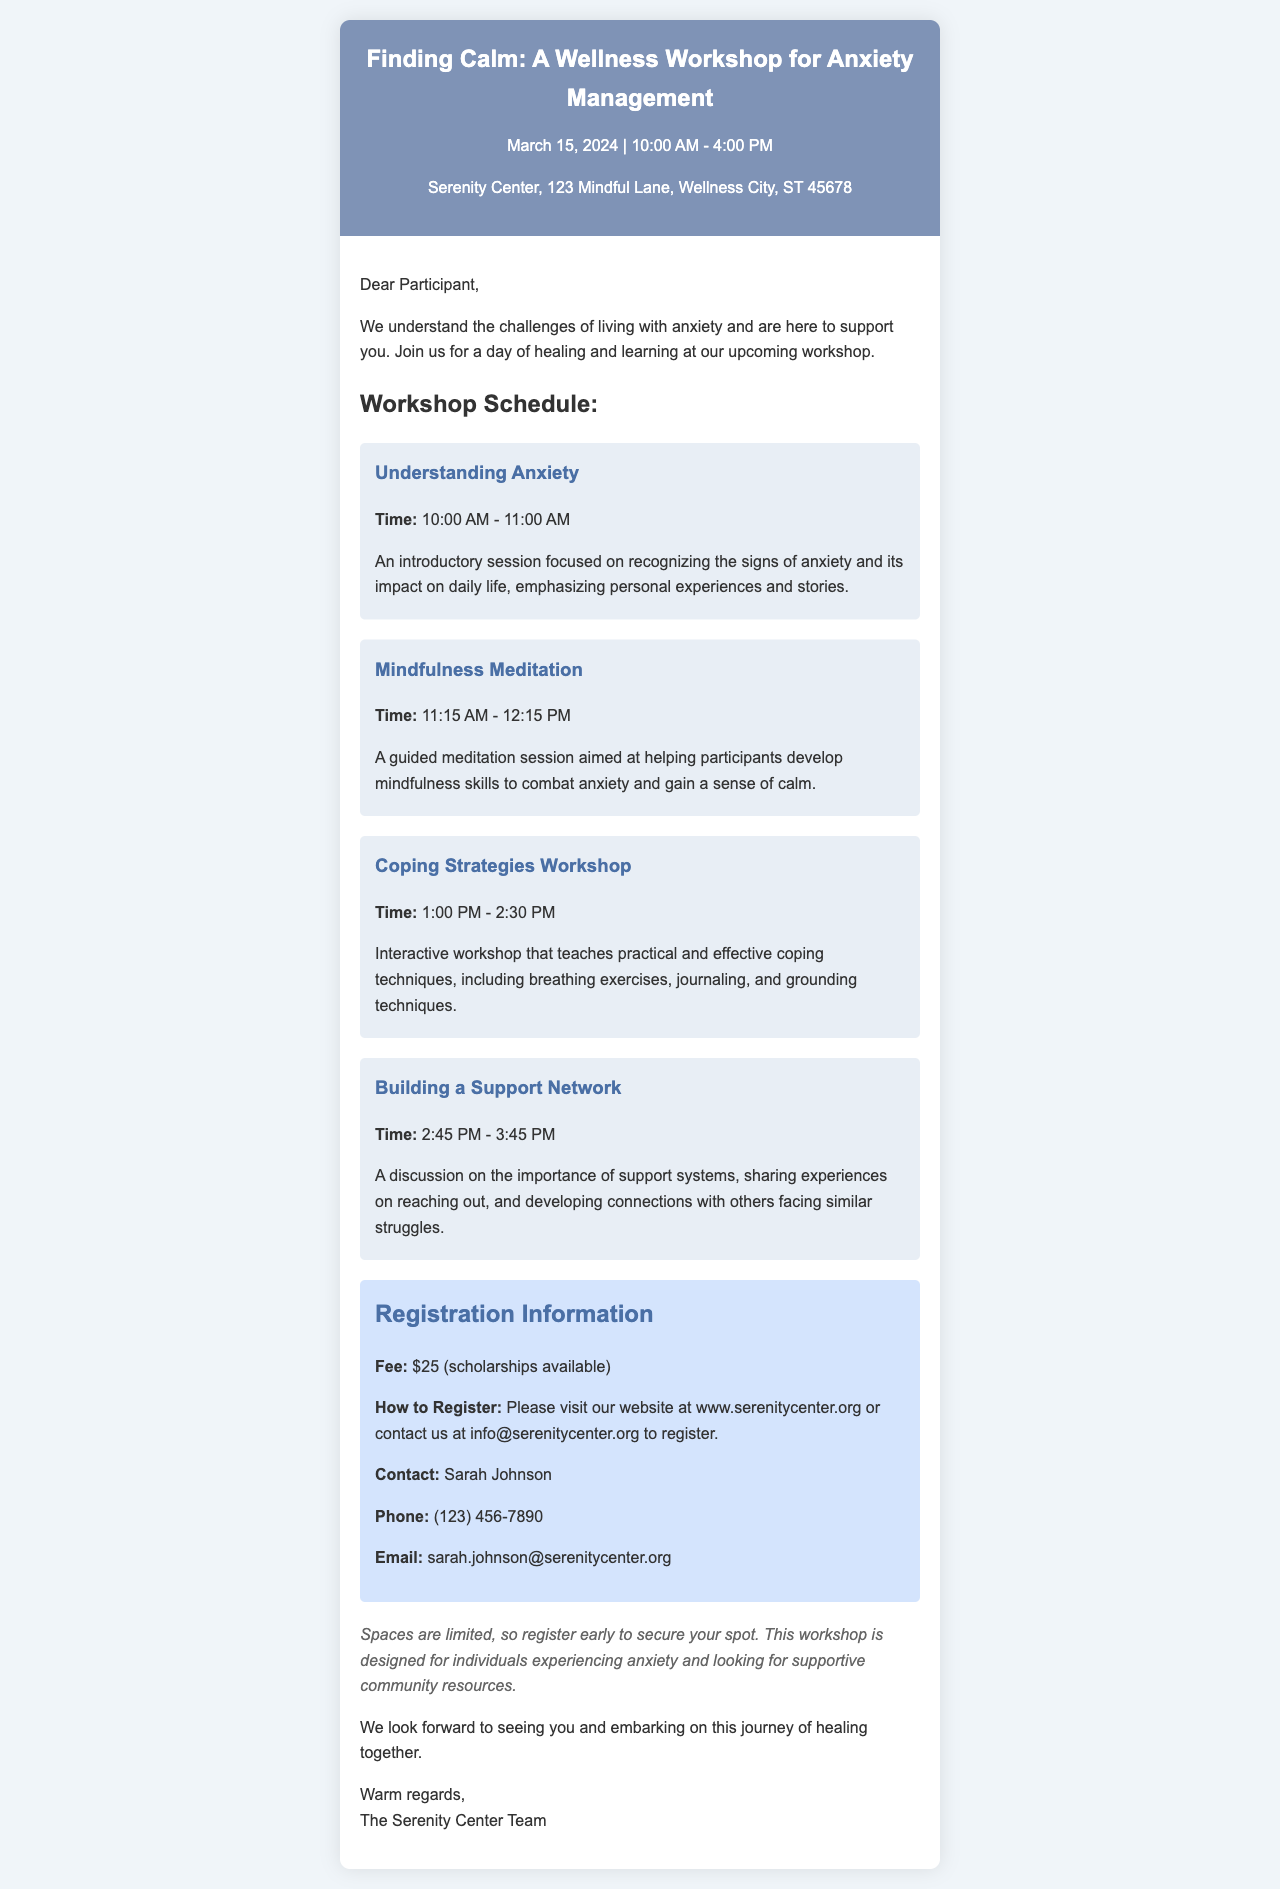What is the date of the workshop? The date of the workshop is mentioned in the header section of the document.
Answer: March 15, 2024 Where is the workshop being held? The location of the workshop is included in the header section of the document.
Answer: Serenity Center, 123 Mindful Lane, Wellness City, ST 45678 What is the registration fee? The registration fee is provided in the registration section of the document.
Answer: $25 Who should participants contact for more information? The contact person for more information is specified in the registration section.
Answer: Sarah Johnson What time does the "Coping Strategies Workshop" start? The start time for this workshop session is listed in the schedule section of the document.
Answer: 1:00 PM What type of techniques will be taught in the "Coping Strategies Workshop"? This session focuses on specific techniques mentioned in the session description.
Answer: Breathing exercises, journaling, and grounding techniques What is the duration of the "Mindfulness Meditation" session? The duration can be calculated from the start and end time provided in the session's description.
Answer: 1 hour What opportunity is available for those who cannot afford the fee? This information is indicated in the registration details.
Answer: Scholarships available What is the primary focus of the workshop? The overall theme of the workshop is stated in the introductory paragraph of the document.
Answer: Anxiety management techniques 